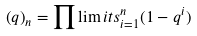Convert formula to latex. <formula><loc_0><loc_0><loc_500><loc_500>\left ( q \right ) _ { n } = \prod \lim i t s _ { i = 1 } ^ { n } ( 1 - q ^ { i } )</formula> 